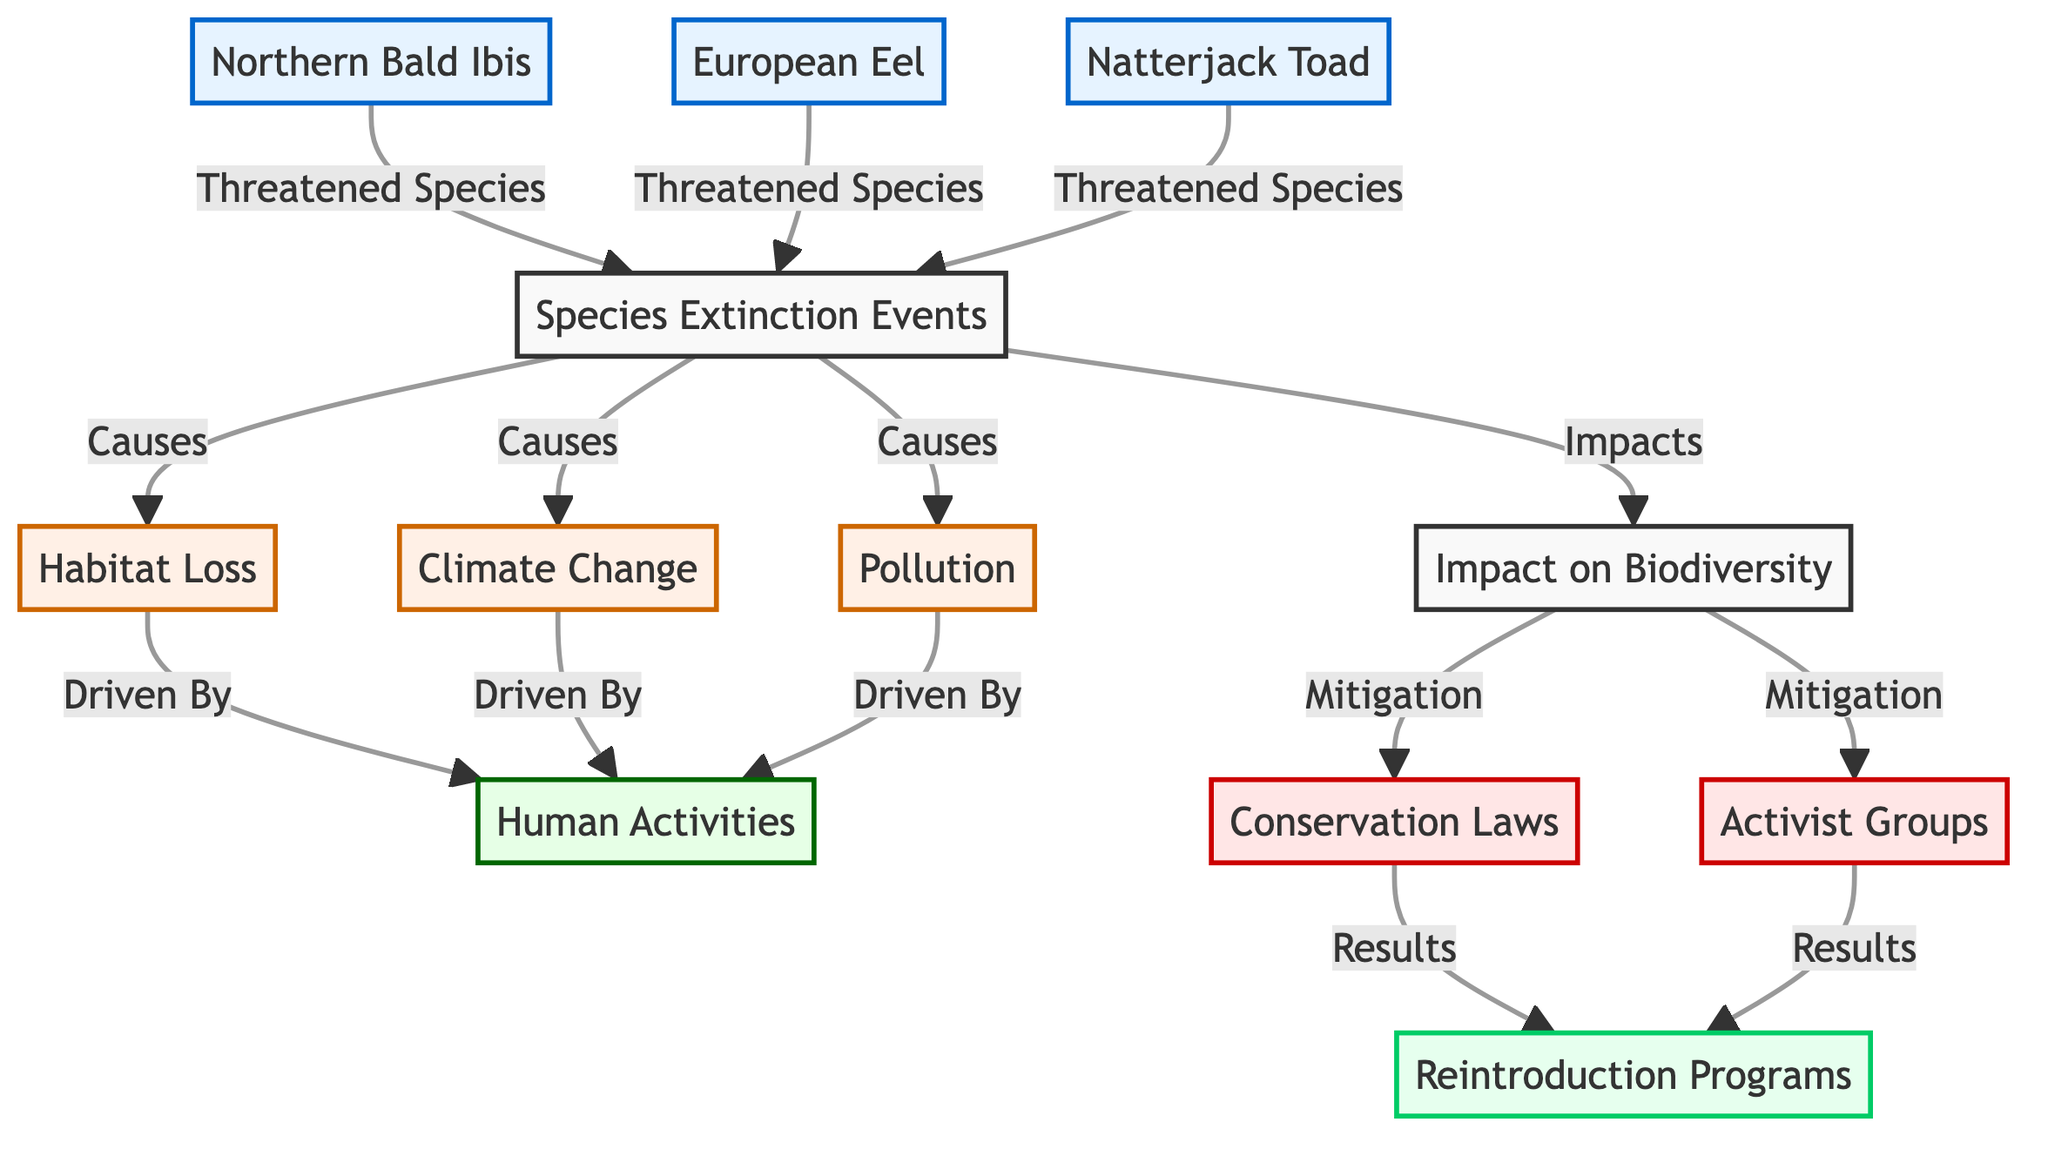What species are identified as threatened in the diagram? The diagram lists three species identified as threatened: Northern Bald Ibis, European Eel, and Natterjack Toad. These species are explicitly linked to the Species Extinction Events node, demonstrating their status.
Answer: Northern Bald Ibis, European Eel, Natterjack Toad How many causes of species extinction are shown in the diagram? The diagram shows three causes linked to species extinction events: Habitat Loss, Climate Change, and Pollution. By counting the causes that are directly connected to the Species Extinction Events node, we see that there are three distinct factors.
Answer: 3 Which human activity is associated with habitat loss, climate change, and pollution? The diagram connects human activities as a driving force for habitat loss, climate change, and pollution, indicating that these activities are the common underlying factors for these environmental issues leading to species extinction.
Answer: Human Activities What is the outcome of conservation laws as represented in the diagram? In the visual representation, conservation laws lead to reintroduction programs, highlighting a direct effect of legal measures aimed at mitigating the impact of species extinction on biodiversity.
Answer: Reintroduction Programs What is the relationship between activist groups and species extinction impacts? The diagram shows a positive relationship where activist groups contribute to mitigating the impacts of species extinction. Their involvement is illustrated as leading to reintroduction programs, which aim to improve biodiversity outcomes.
Answer: Mitigation of impacts Explain the flow from species extinction events to biodiversity impact and name a threat factor. The diagram illustrates that species extinction events have direct impacts on biodiversity. Each extinction event is driven by various factors, including habitat loss, which acts as one primary threat. Thus, we see a connection from extinction events to negative impacts on biodiversity, with habitat loss designated as a notable threat factor.
Answer: Habitat Loss 